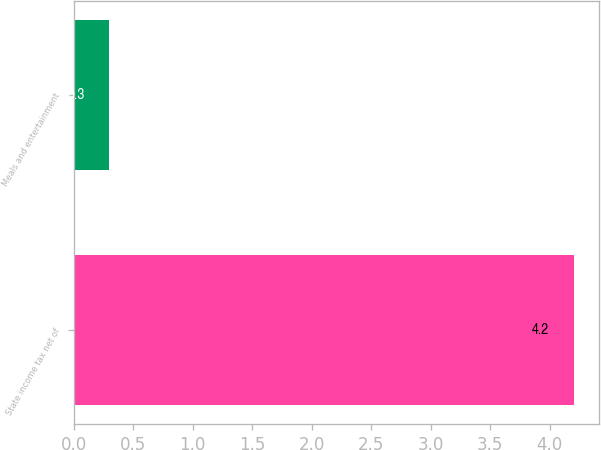Convert chart to OTSL. <chart><loc_0><loc_0><loc_500><loc_500><bar_chart><fcel>State income tax net of<fcel>Meals and entertainment<nl><fcel>4.2<fcel>0.3<nl></chart> 